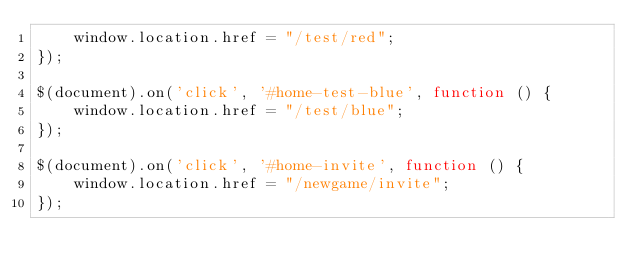Convert code to text. <code><loc_0><loc_0><loc_500><loc_500><_JavaScript_>    window.location.href = "/test/red";
});

$(document).on('click', '#home-test-blue', function () {
    window.location.href = "/test/blue";
});

$(document).on('click', '#home-invite', function () {
    window.location.href = "/newgame/invite";
});</code> 